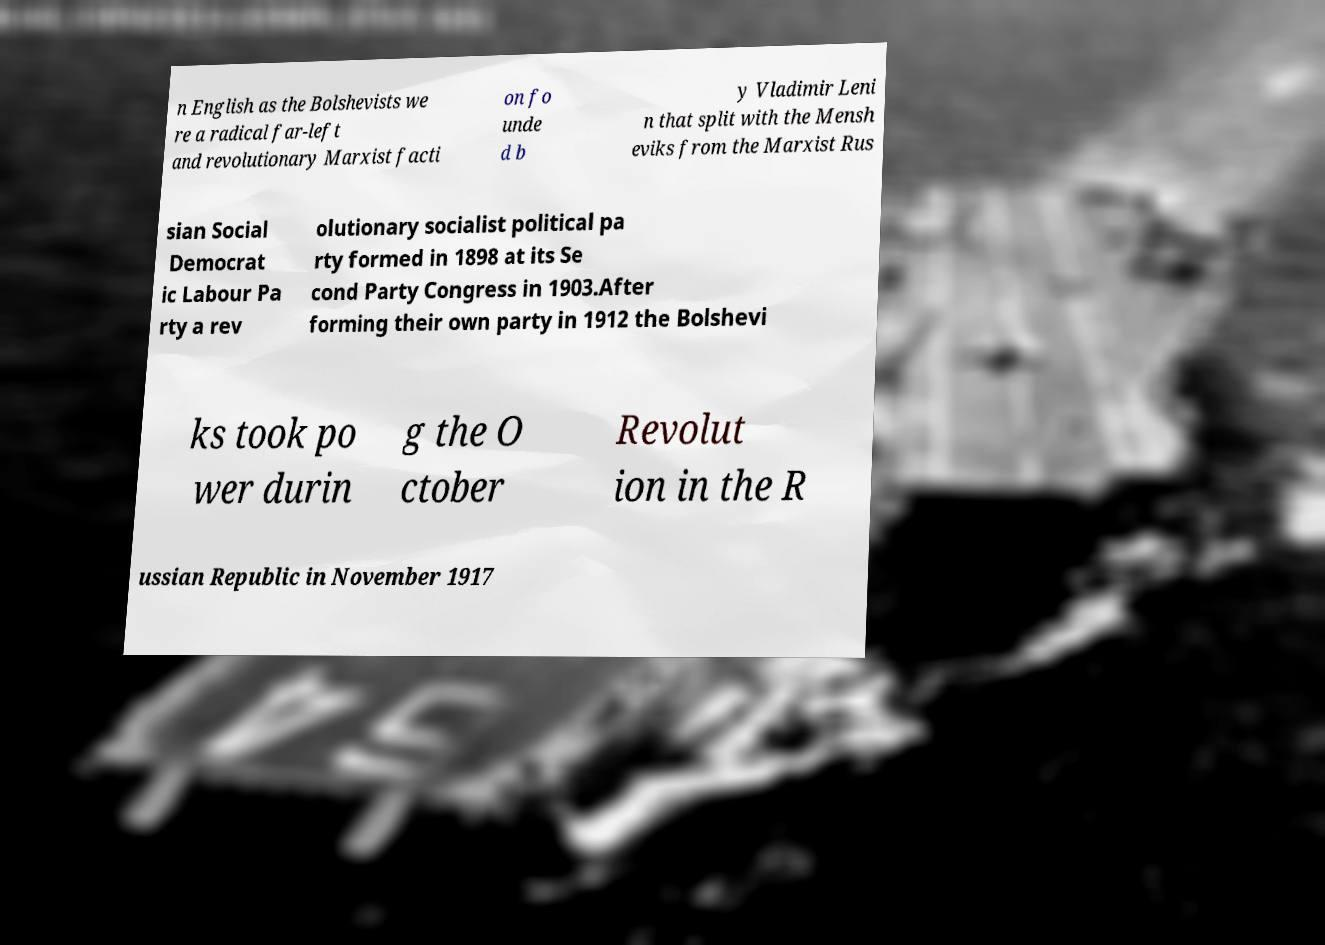I need the written content from this picture converted into text. Can you do that? n English as the Bolshevists we re a radical far-left and revolutionary Marxist facti on fo unde d b y Vladimir Leni n that split with the Mensh eviks from the Marxist Rus sian Social Democrat ic Labour Pa rty a rev olutionary socialist political pa rty formed in 1898 at its Se cond Party Congress in 1903.After forming their own party in 1912 the Bolshevi ks took po wer durin g the O ctober Revolut ion in the R ussian Republic in November 1917 